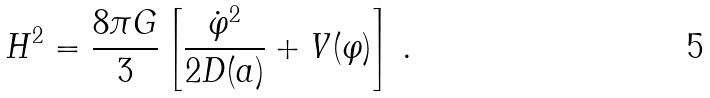Convert formula to latex. <formula><loc_0><loc_0><loc_500><loc_500>H ^ { 2 } = \frac { 8 \pi G } { 3 } \left [ \frac { \dot { \varphi } ^ { 2 } } { 2 D ( a ) } + V ( \varphi ) \right ] \, .</formula> 